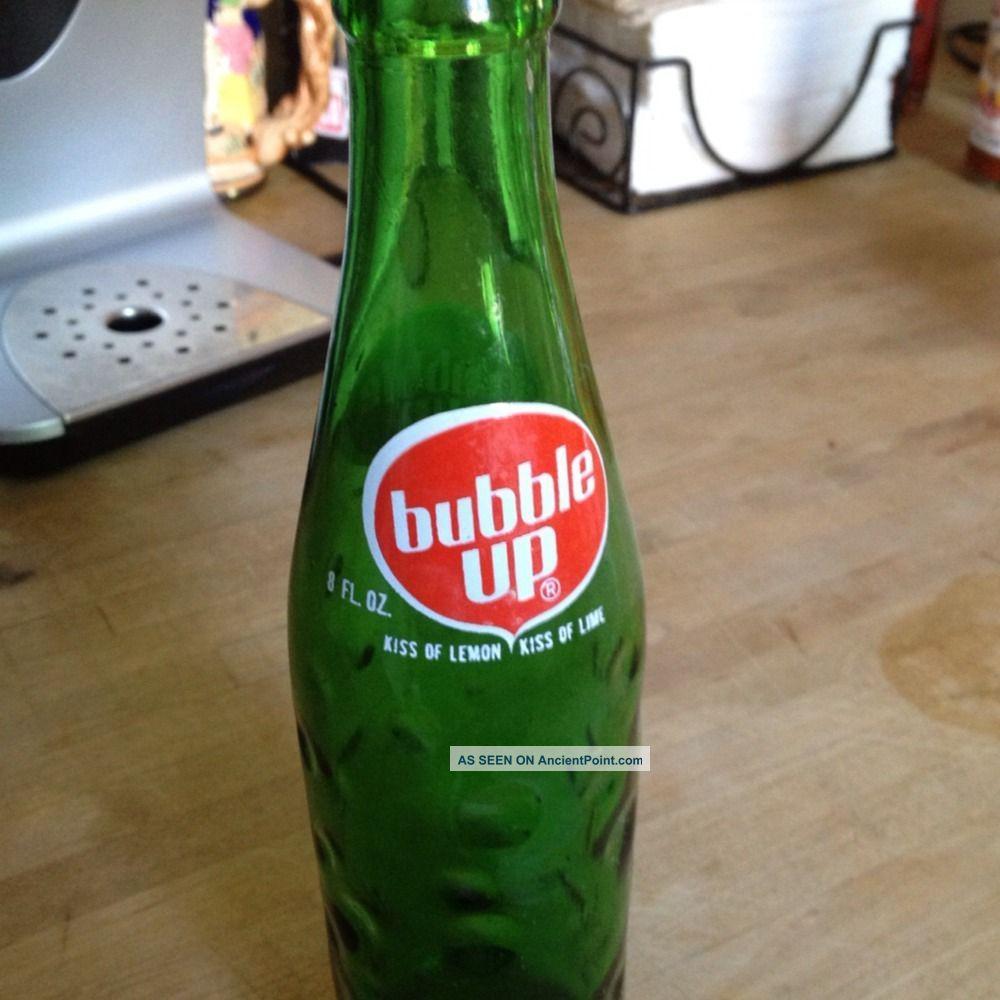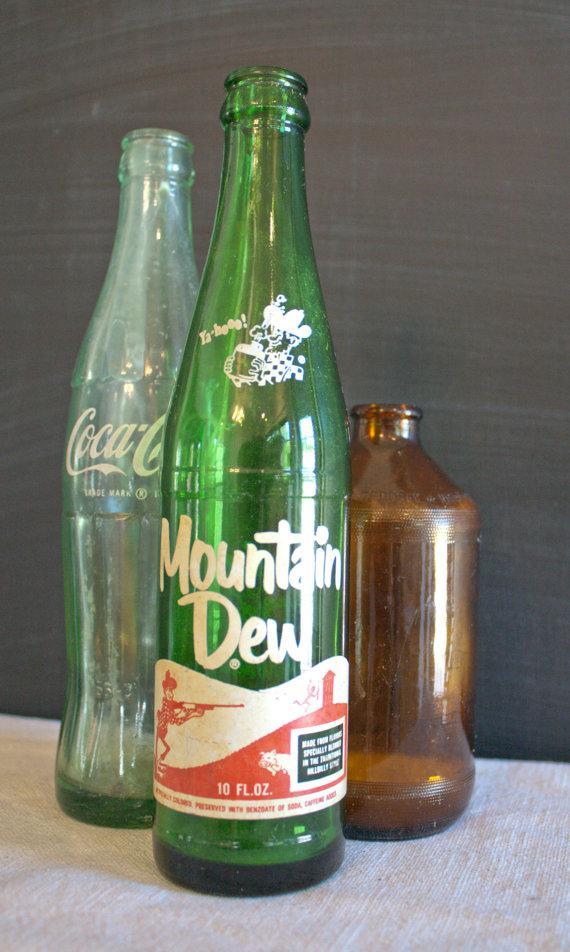The first image is the image on the left, the second image is the image on the right. Assess this claim about the two images: "Each image contains a single green glass soda bottle, and at least one bottle depicted has overlapping white circle shapes on its front.". Correct or not? Answer yes or no. No. The first image is the image on the left, the second image is the image on the right. Examine the images to the left and right. Is the description "Has atleast one picture of a drink that isn't Bubble Up" accurate? Answer yes or no. Yes. 